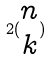<formula> <loc_0><loc_0><loc_500><loc_500>2 ( \begin{matrix} n \\ k \end{matrix} )</formula> 